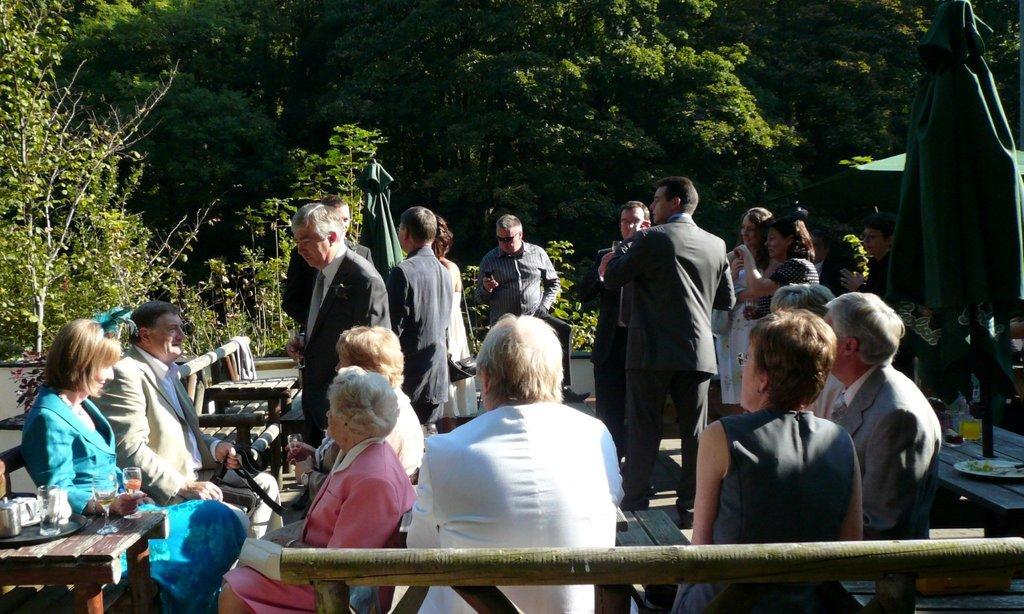Please provide a concise description of this image. In the foreground of the picture there are many people and there are benches, plates, glasses, umbrella, food items and other objects. In the background there are trees. 